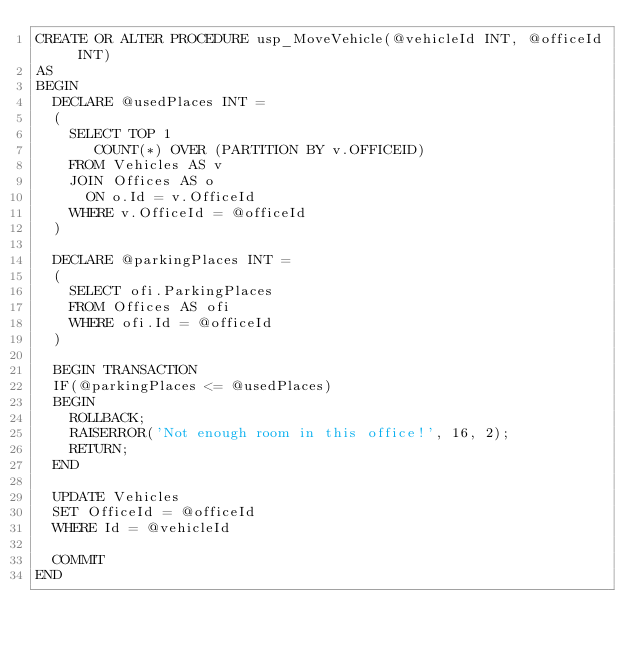Convert code to text. <code><loc_0><loc_0><loc_500><loc_500><_SQL_>CREATE OR ALTER PROCEDURE usp_MoveVehicle(@vehicleId INT, @officeId INT)
AS 
BEGIN
	DECLARE @usedPlaces INT =  
	(
		SELECT TOP 1 
			 COUNT(*) OVER (PARTITION BY v.OFFICEID)
		FROM Vehicles AS v
		JOIN Offices AS o
			ON o.Id = v.OfficeId
		WHERE v.OfficeId = @officeId
	)

	DECLARE @parkingPlaces INT = 
	(
		SELECT ofi.ParkingPlaces 
		FROM Offices AS ofi
		WHERE ofi.Id = @officeId
	)

	BEGIN TRANSACTION 
	IF(@parkingPlaces <= @usedPlaces)
	BEGIN 
		ROLLBACK; 
		RAISERROR('Not enough room in this office!', 16, 2); 
		RETURN;
	END

	UPDATE Vehicles
	SET OfficeId = @officeId 
	WHERE Id = @vehicleId

	COMMIT
END	
</code> 